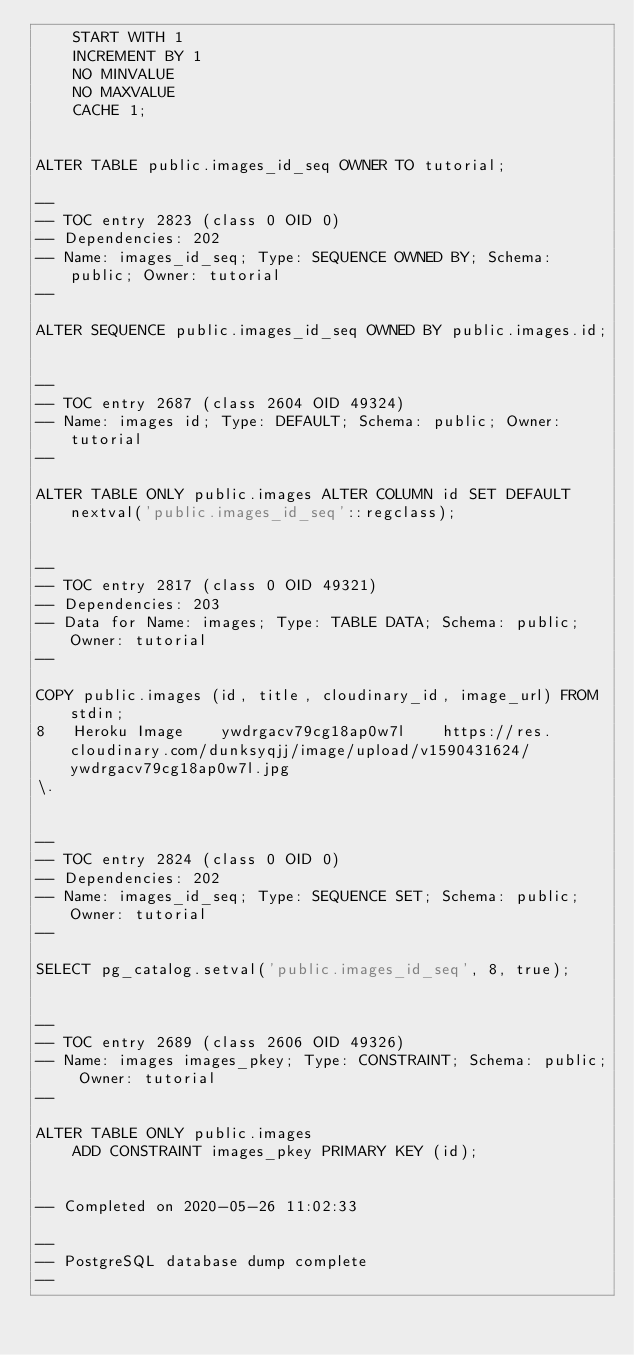Convert code to text. <code><loc_0><loc_0><loc_500><loc_500><_SQL_>    START WITH 1
    INCREMENT BY 1
    NO MINVALUE
    NO MAXVALUE
    CACHE 1;


ALTER TABLE public.images_id_seq OWNER TO tutorial;

--
-- TOC entry 2823 (class 0 OID 0)
-- Dependencies: 202
-- Name: images_id_seq; Type: SEQUENCE OWNED BY; Schema: public; Owner: tutorial
--

ALTER SEQUENCE public.images_id_seq OWNED BY public.images.id;


--
-- TOC entry 2687 (class 2604 OID 49324)
-- Name: images id; Type: DEFAULT; Schema: public; Owner: tutorial
--

ALTER TABLE ONLY public.images ALTER COLUMN id SET DEFAULT nextval('public.images_id_seq'::regclass);


--
-- TOC entry 2817 (class 0 OID 49321)
-- Dependencies: 203
-- Data for Name: images; Type: TABLE DATA; Schema: public; Owner: tutorial
--

COPY public.images (id, title, cloudinary_id, image_url) FROM stdin;
8	Heroku Image	ywdrgacv79cg18ap0w7l	https://res.cloudinary.com/dunksyqjj/image/upload/v1590431624/ywdrgacv79cg18ap0w7l.jpg
\.


--
-- TOC entry 2824 (class 0 OID 0)
-- Dependencies: 202
-- Name: images_id_seq; Type: SEQUENCE SET; Schema: public; Owner: tutorial
--

SELECT pg_catalog.setval('public.images_id_seq', 8, true);


--
-- TOC entry 2689 (class 2606 OID 49326)
-- Name: images images_pkey; Type: CONSTRAINT; Schema: public; Owner: tutorial
--

ALTER TABLE ONLY public.images
    ADD CONSTRAINT images_pkey PRIMARY KEY (id);


-- Completed on 2020-05-26 11:02:33

--
-- PostgreSQL database dump complete
--

</code> 